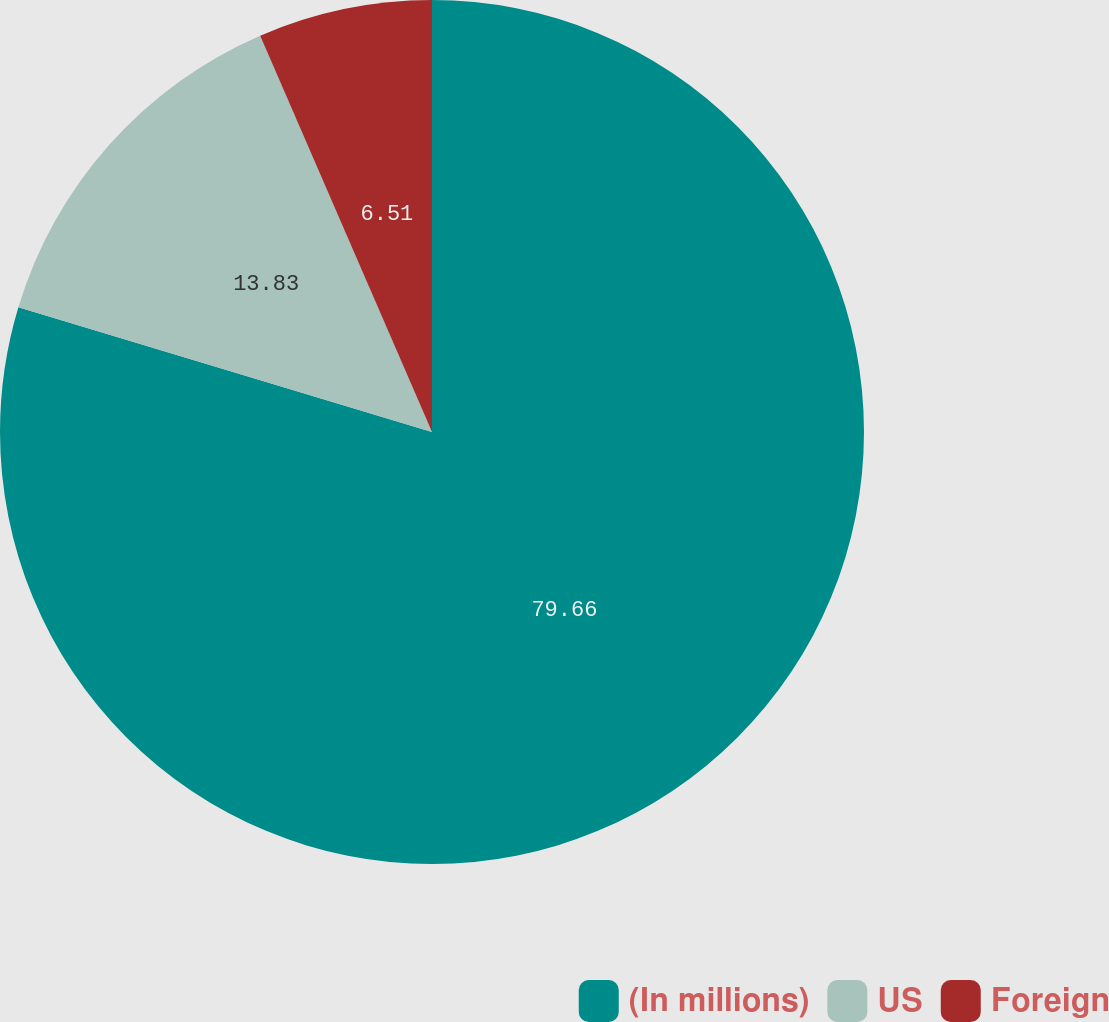Convert chart to OTSL. <chart><loc_0><loc_0><loc_500><loc_500><pie_chart><fcel>(In millions)<fcel>US<fcel>Foreign<nl><fcel>79.66%<fcel>13.83%<fcel>6.51%<nl></chart> 